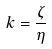<formula> <loc_0><loc_0><loc_500><loc_500>k = \frac { \zeta } { \eta }</formula> 